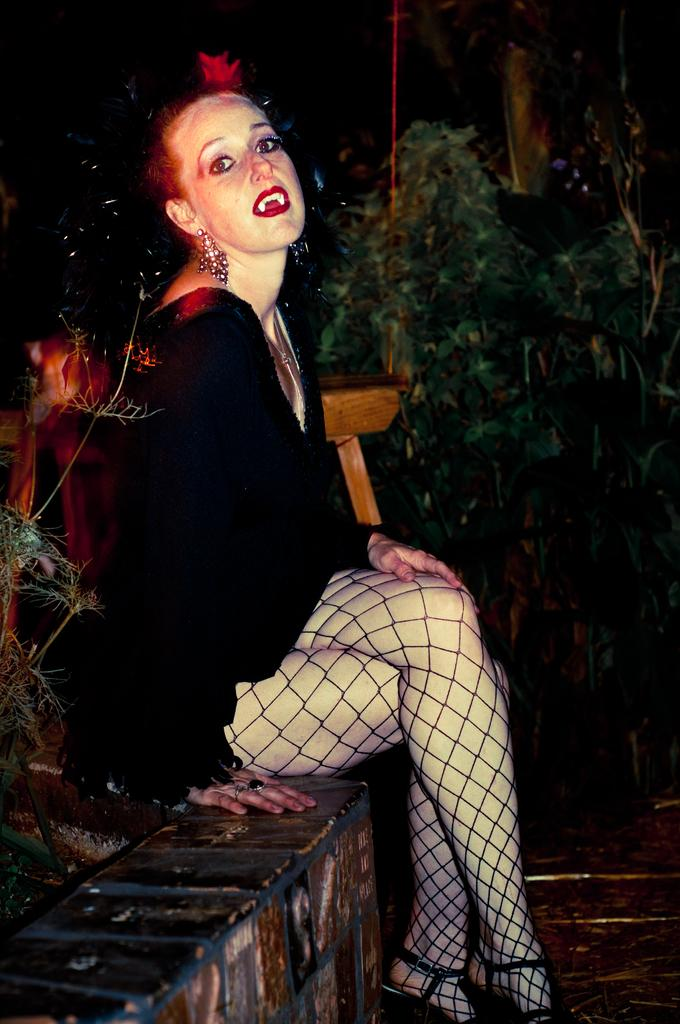What is the woman in the image doing? The woman is sitting on the pavement in the image. What can be seen in the background of the image? There are trees visible in the background of the image. What color is the ant crawling on the woman's scarf in the image? There is no ant or scarf present in the image. What is the position of the sun in the image? The position of the sun is not mentioned in the provided facts, and there is no indication of the sun's presence in the image. 